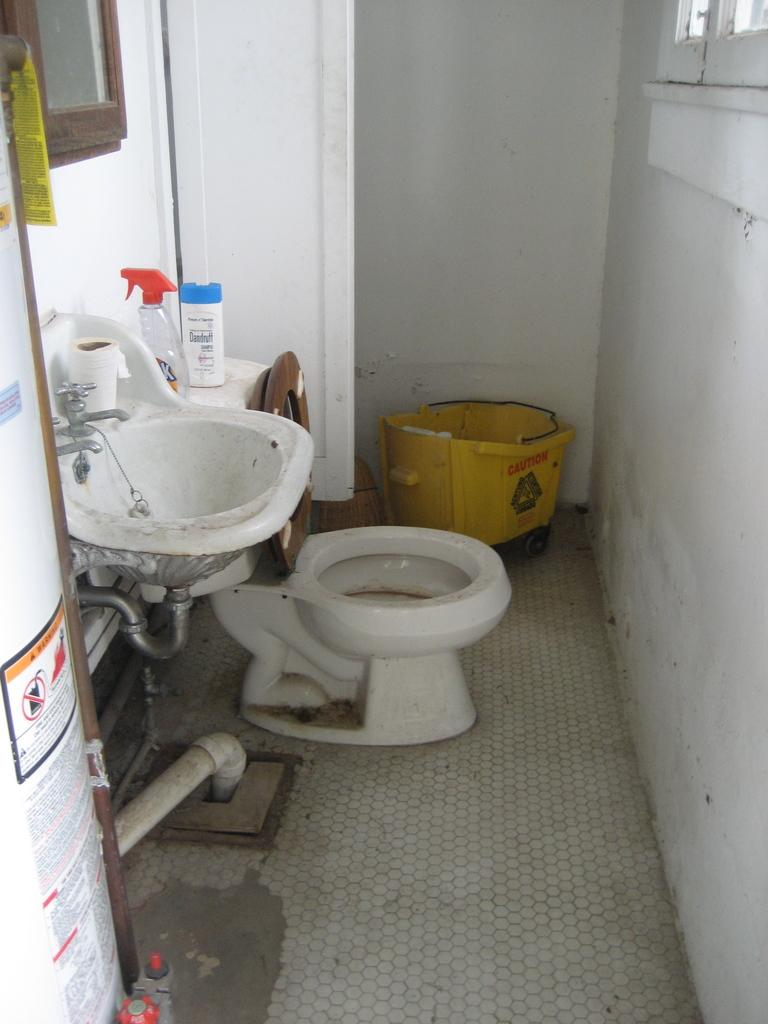What is the main structure in the center of the image? There is a wall in the center of the image. What can be found near the wall? There is a sink in the image. What color is the prominent object in the image? There is a yellow color object in the image. What type of fixture is present in the image? There is a bowl toilet in the image. What are the small containers in the image? There are bottles in the image. What type of decorations are on the wall? There are posters with text in the image. What can be used to control the flow of water in the image? There are taps in the image. What other objects can be seen in the image? There are a few other objects in the image. What type of celery is being used as a decoration in the image? There is no celery present in the image; it is a bathroom setting with a wall, sink, yellow object, bowl toilet, bottles, posters with text, taps, and other objects. How many family members can be seen in the image? There are no family members present in the image; it is a bathroom setting with a wall, sink, yellow object, bowl toilet, bottles, posters with text, taps, and other objects. 